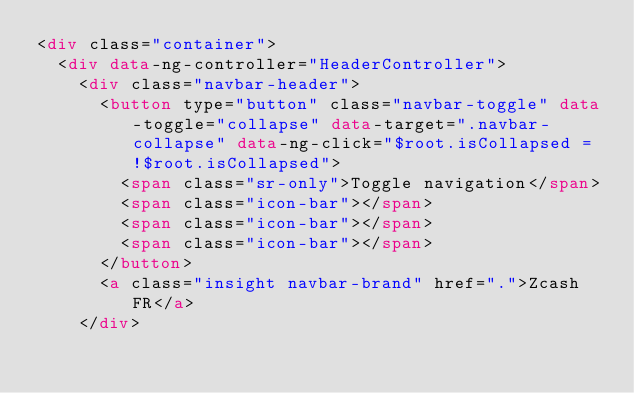<code> <loc_0><loc_0><loc_500><loc_500><_HTML_><div class="container">
  <div data-ng-controller="HeaderController">
    <div class="navbar-header">
      <button type="button" class="navbar-toggle" data-toggle="collapse" data-target=".navbar-collapse" data-ng-click="$root.isCollapsed = !$root.isCollapsed">
        <span class="sr-only">Toggle navigation</span>
        <span class="icon-bar"></span>
        <span class="icon-bar"></span>
        <span class="icon-bar"></span>
      </button>
      <a class="insight navbar-brand" href=".">Zcash FR</a>
    </div></code> 